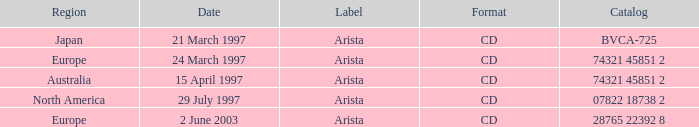What is mentioned for the label dated 29th july 1997? Arista. 